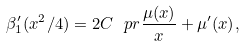Convert formula to latex. <formula><loc_0><loc_0><loc_500><loc_500>\beta _ { 1 } ^ { \prime } ( x ^ { 2 } / 4 ) = 2 C \ p r { \frac { \mu ( x ) } { x } + \mu ^ { \prime } ( x ) } ,</formula> 